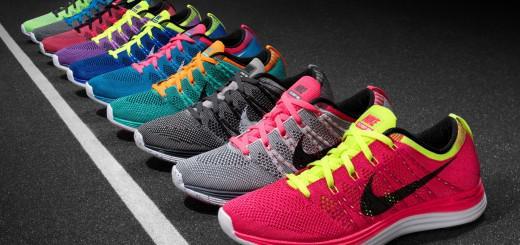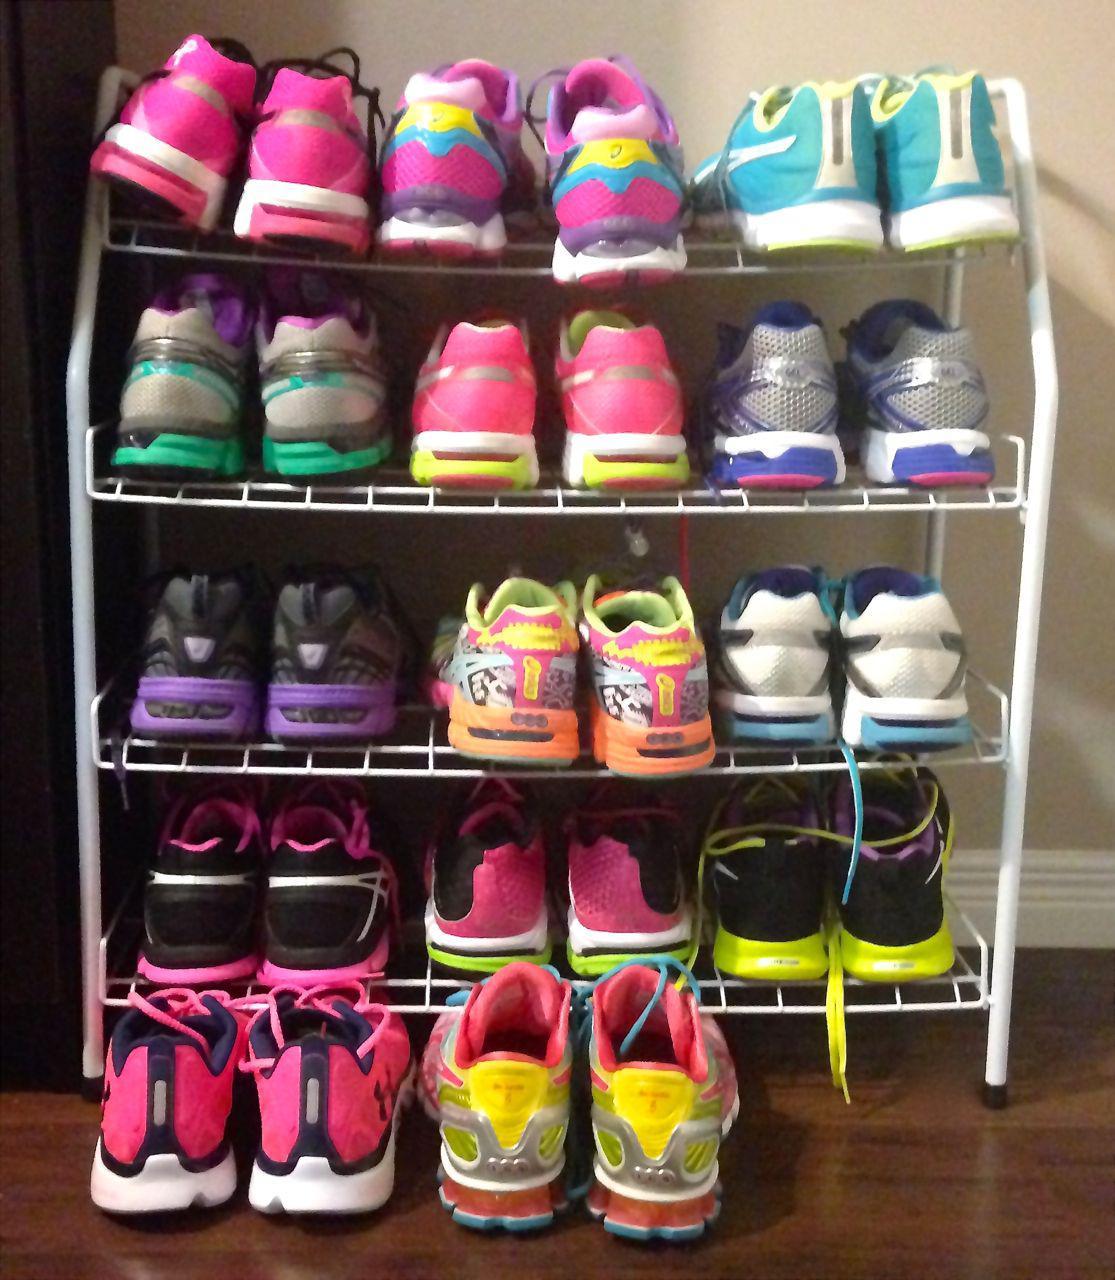The first image is the image on the left, the second image is the image on the right. Evaluate the accuracy of this statement regarding the images: "The image on the right in the pair has fewer than five sneakers.". Is it true? Answer yes or no. No. The first image is the image on the left, the second image is the image on the right. Assess this claim about the two images: "In the image on the left, a red and yellow shoe is sitting on the right side of the row.". Correct or not? Answer yes or no. Yes. 